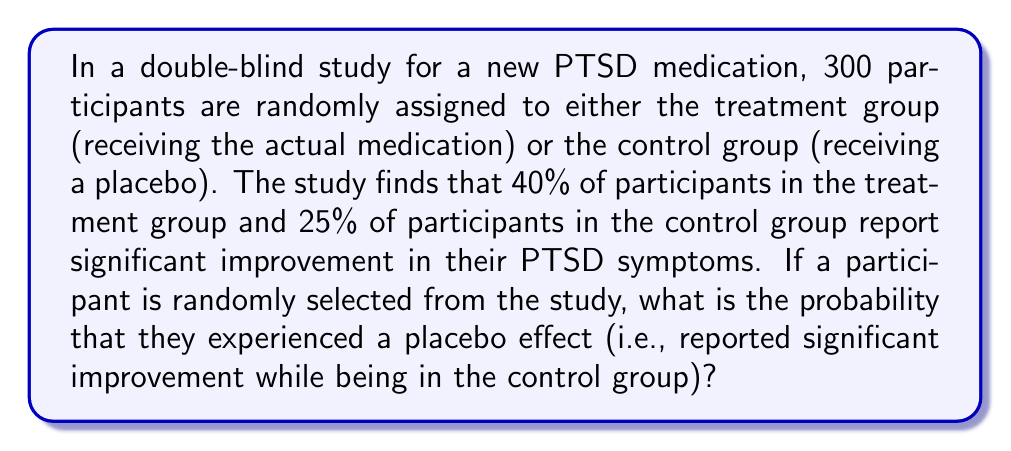Can you solve this math problem? Let's approach this step-by-step:

1) First, we need to determine the number of participants in each group. Since it's a randomized study, we can assume an equal split:
   Treatment group: 150 participants
   Control group: 150 participants

2) Now, let's calculate the number of participants who reported significant improvement in each group:
   Treatment group: $40\% \text{ of } 150 = 0.40 \times 150 = 60$ participants
   Control group: $25\% \text{ of } 150 = 0.25 \times 150 = 37.5 \approx 38$ participants

3) The placebo effect occurs when a participant in the control group reports significant improvement. This is the 38 participants we calculated in the control group.

4) To find the probability, we need to divide the number of participants experiencing the placebo effect by the total number of participants:

   $$P(\text{placebo effect}) = \frac{\text{Number of participants with placebo effect}}{\text{Total number of participants}}$$

   $$P(\text{placebo effect}) = \frac{38}{300} = \frac{19}{150} \approx 0.1267$$

5) Therefore, the probability of randomly selecting a participant who experienced the placebo effect is approximately 0.1267 or 12.67%.
Answer: $\frac{19}{150} \approx 0.1267$ or $12.67\%$ 